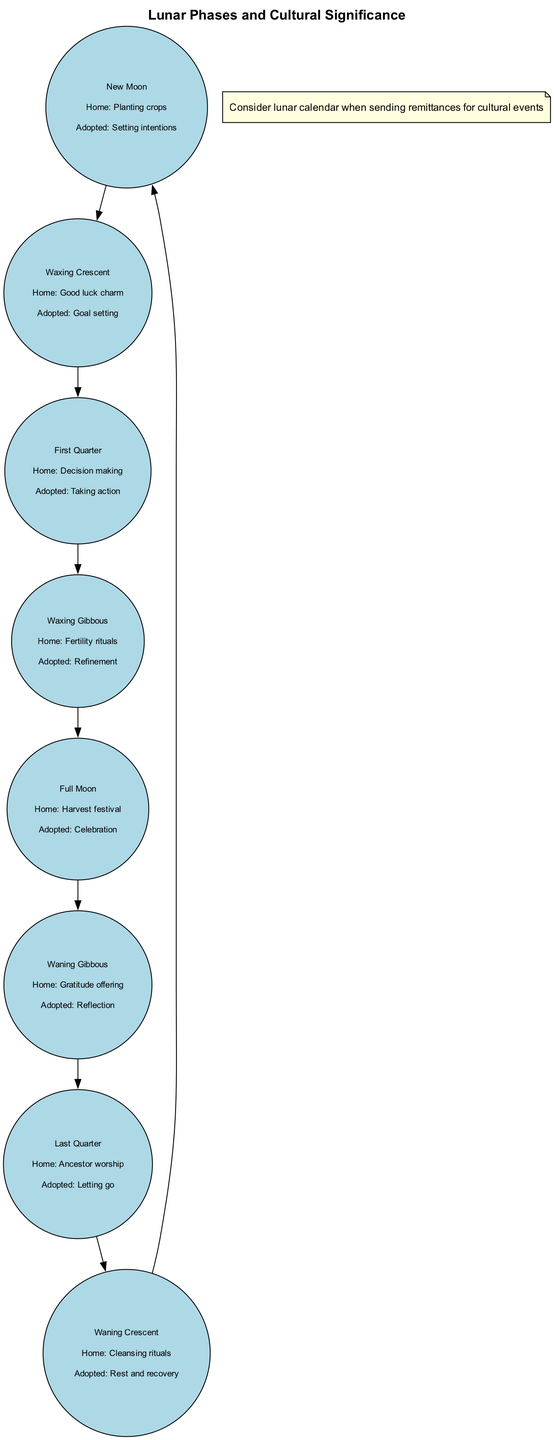What is the cultural significance of the Full Moon in the home country? The diagram shows that the Full Moon is associated with the "Harvest festival" in the home country. This information can be found directly under the Full Moon's node in the diagram.
Answer: Harvest festival What does the Waxing Crescent phase signify in the adopted country? According to the diagram, the Waxing Crescent phase is linked to "Goal setting" in the adopted country, which is noted directly beneath its phase description in the diagram.
Answer: Goal setting How many phases of the moon are represented in the diagram? The diagram contains eight distinct moon phases listed sequentially, which can be counted from the nodes created for each phase.
Answer: 8 What is the significance of the New Moon in the adopted country? The diagram indicates that the New Moon is associated with "Setting intentions" in the adopted country as stated under the New Moon node.
Answer: Setting intentions What phase is associated with Ancestor worship in the home country? By reviewing the diagram, we can see under the Last Quarter phase that it signifies "Ancestor worship" in the home country. Thus, this information helps identify the correct association directly.
Answer: Last Quarter What is the cultural significance of the Waxing Gibbous phase in the home country? The Waxing Gibbous phase is noted for "Fertility rituals" in the home country, which is visible beneath the Waxing Gibbous node in the diagram. The answer is derived directly from this node.
Answer: Fertility rituals Which moon phase comes after the First Quarter? From the diagram, we can see that the phase that follows the First Quarter is the Waxing Gibbous, which is achieved by observing the connections made between the nodes in sequence.
Answer: Waxing Gibbous What is the significance of the Waning Crescent in the adopted country? The diagram directly states that the significance of the Waning Crescent phase in the adopted country is associated with "Rest and recovery," which can be found directly under its description in the diagram.
Answer: Rest and recovery 